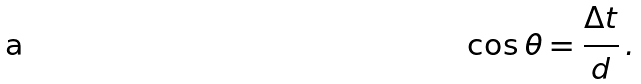Convert formula to latex. <formula><loc_0><loc_0><loc_500><loc_500>\cos \theta = \frac { \Delta t } { d } \, .</formula> 